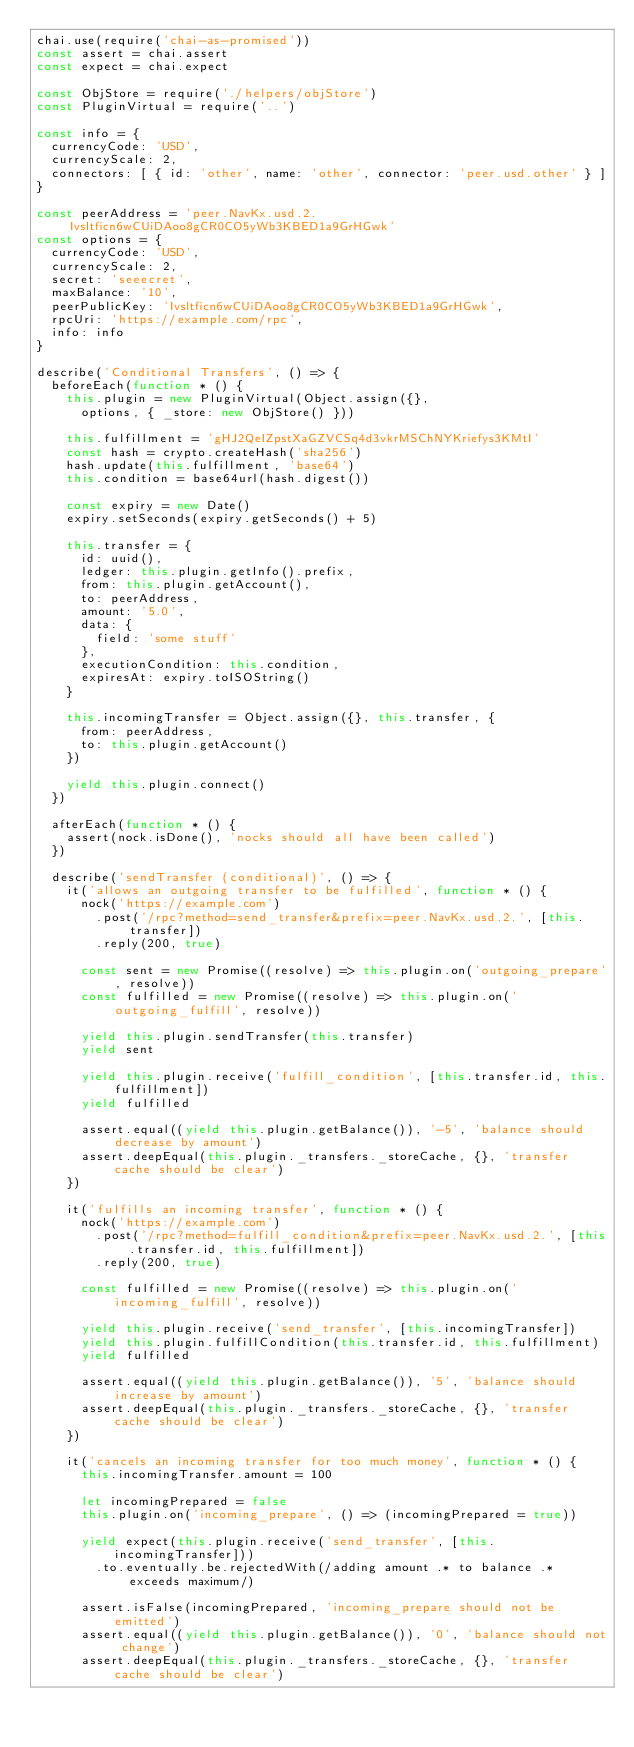Convert code to text. <code><loc_0><loc_0><loc_500><loc_500><_JavaScript_>chai.use(require('chai-as-promised'))
const assert = chai.assert
const expect = chai.expect

const ObjStore = require('./helpers/objStore')
const PluginVirtual = require('..')

const info = {
  currencyCode: 'USD',
  currencyScale: 2,
  connectors: [ { id: 'other', name: 'other', connector: 'peer.usd.other' } ]
}

const peerAddress = 'peer.NavKx.usd.2.Ivsltficn6wCUiDAoo8gCR0CO5yWb3KBED1a9GrHGwk'
const options = {
  currencyCode: 'USD',
  currencyScale: 2,
  secret: 'seeecret',
  maxBalance: '10',
  peerPublicKey: 'Ivsltficn6wCUiDAoo8gCR0CO5yWb3KBED1a9GrHGwk',
  rpcUri: 'https://example.com/rpc',
  info: info
}

describe('Conditional Transfers', () => {
  beforeEach(function * () {
    this.plugin = new PluginVirtual(Object.assign({},
      options, { _store: new ObjStore() }))

    this.fulfillment = 'gHJ2QeIZpstXaGZVCSq4d3vkrMSChNYKriefys3KMtI'
    const hash = crypto.createHash('sha256')
    hash.update(this.fulfillment, 'base64')
    this.condition = base64url(hash.digest())

    const expiry = new Date()
    expiry.setSeconds(expiry.getSeconds() + 5)

    this.transfer = {
      id: uuid(),
      ledger: this.plugin.getInfo().prefix,
      from: this.plugin.getAccount(),
      to: peerAddress,
      amount: '5.0',
      data: {
        field: 'some stuff'
      },
      executionCondition: this.condition,
      expiresAt: expiry.toISOString()
    }

    this.incomingTransfer = Object.assign({}, this.transfer, {
      from: peerAddress,
      to: this.plugin.getAccount()
    })

    yield this.plugin.connect()
  })

  afterEach(function * () {
    assert(nock.isDone(), 'nocks should all have been called')
  })

  describe('sendTransfer (conditional)', () => {
    it('allows an outgoing transfer to be fulfilled', function * () {
      nock('https://example.com')
        .post('/rpc?method=send_transfer&prefix=peer.NavKx.usd.2.', [this.transfer])
        .reply(200, true)

      const sent = new Promise((resolve) => this.plugin.on('outgoing_prepare', resolve))
      const fulfilled = new Promise((resolve) => this.plugin.on('outgoing_fulfill', resolve))

      yield this.plugin.sendTransfer(this.transfer)
      yield sent

      yield this.plugin.receive('fulfill_condition', [this.transfer.id, this.fulfillment])
      yield fulfilled

      assert.equal((yield this.plugin.getBalance()), '-5', 'balance should decrease by amount')
      assert.deepEqual(this.plugin._transfers._storeCache, {}, 'transfer cache should be clear')
    })

    it('fulfills an incoming transfer', function * () {
      nock('https://example.com')
        .post('/rpc?method=fulfill_condition&prefix=peer.NavKx.usd.2.', [this.transfer.id, this.fulfillment])
        .reply(200, true)

      const fulfilled = new Promise((resolve) => this.plugin.on('incoming_fulfill', resolve))

      yield this.plugin.receive('send_transfer', [this.incomingTransfer])
      yield this.plugin.fulfillCondition(this.transfer.id, this.fulfillment)
      yield fulfilled

      assert.equal((yield this.plugin.getBalance()), '5', 'balance should increase by amount')
      assert.deepEqual(this.plugin._transfers._storeCache, {}, 'transfer cache should be clear')
    })

    it('cancels an incoming transfer for too much money', function * () {
      this.incomingTransfer.amount = 100

      let incomingPrepared = false
      this.plugin.on('incoming_prepare', () => (incomingPrepared = true))

      yield expect(this.plugin.receive('send_transfer', [this.incomingTransfer]))
        .to.eventually.be.rejectedWith(/adding amount .* to balance .* exceeds maximum/)

      assert.isFalse(incomingPrepared, 'incoming_prepare should not be emitted')
      assert.equal((yield this.plugin.getBalance()), '0', 'balance should not change')
      assert.deepEqual(this.plugin._transfers._storeCache, {}, 'transfer cache should be clear')
</code> 